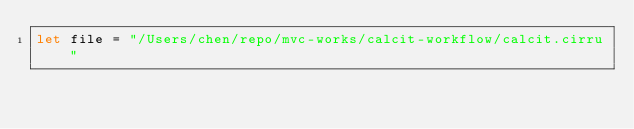Convert code to text. <code><loc_0><loc_0><loc_500><loc_500><_Nim_>let file = "/Users/chen/repo/mvc-works/calcit-workflow/calcit.cirru"
</code> 